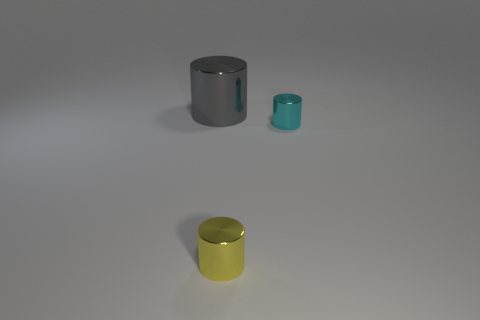Add 3 cyan things. How many objects exist? 6 Add 2 yellow things. How many yellow things are left? 3 Add 2 big gray metal objects. How many big gray metal objects exist? 3 Subtract 0 gray spheres. How many objects are left? 3 Subtract all large green matte cylinders. Subtract all tiny shiny objects. How many objects are left? 1 